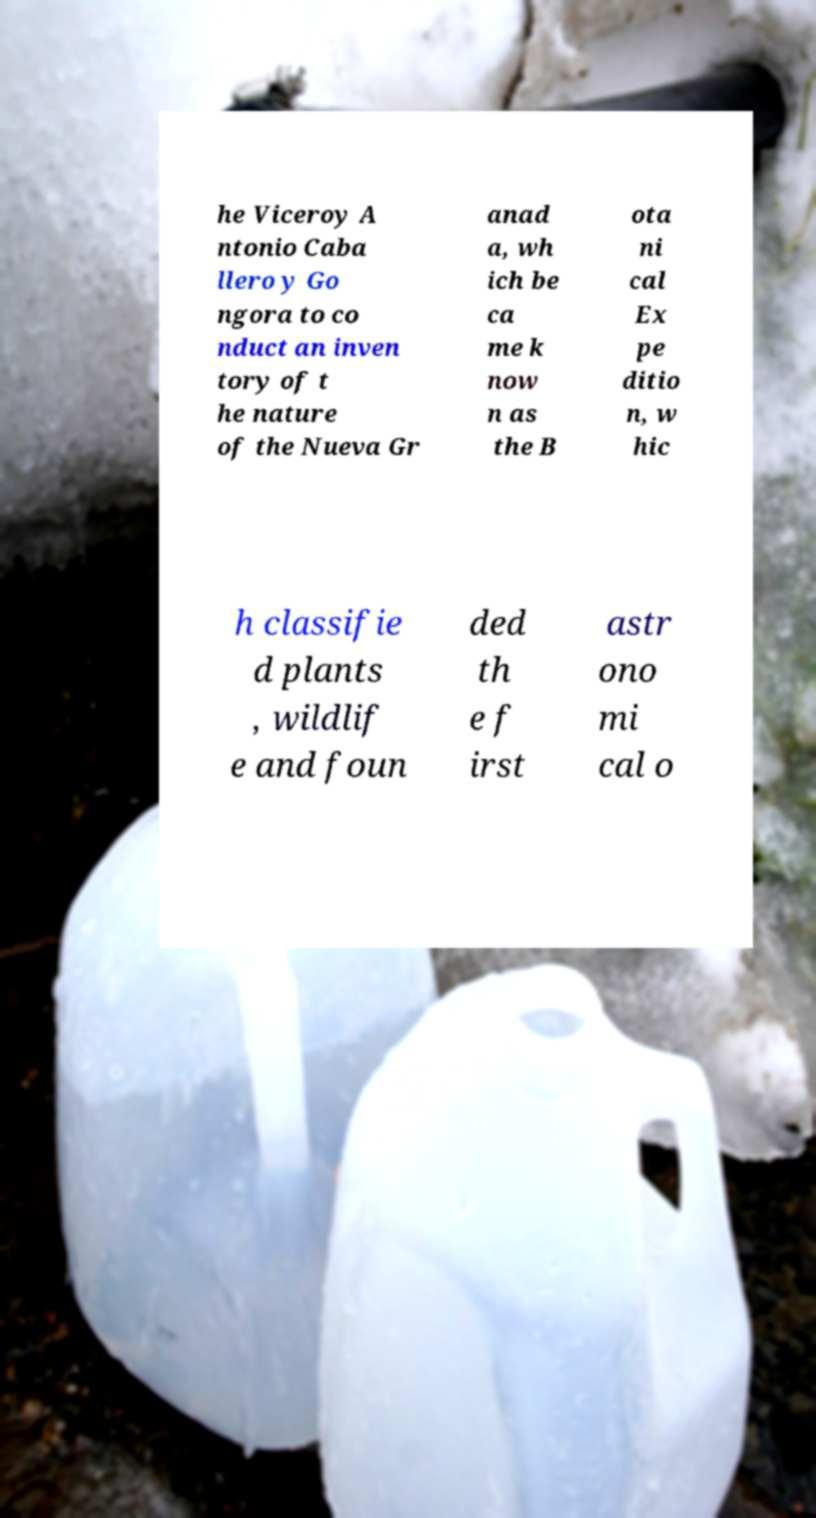Please read and relay the text visible in this image. What does it say? he Viceroy A ntonio Caba llero y Go ngora to co nduct an inven tory of t he nature of the Nueva Gr anad a, wh ich be ca me k now n as the B ota ni cal Ex pe ditio n, w hic h classifie d plants , wildlif e and foun ded th e f irst astr ono mi cal o 